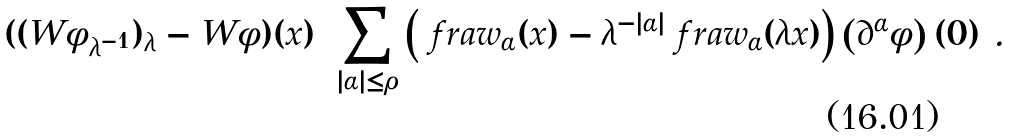Convert formula to latex. <formula><loc_0><loc_0><loc_500><loc_500>( ( W \phi _ { \lambda ^ { - 1 } } ) _ { \lambda } - W \phi ) ( x ) = \sum _ { | \alpha | \leq \rho } \left ( \ f r a { w } _ { \alpha } ( x ) - \lambda ^ { - | \alpha | } \ f r a { w } _ { \alpha } ( \lambda x ) \right ) \left ( \partial ^ { \alpha } \phi \right ) ( 0 ) \ .</formula> 